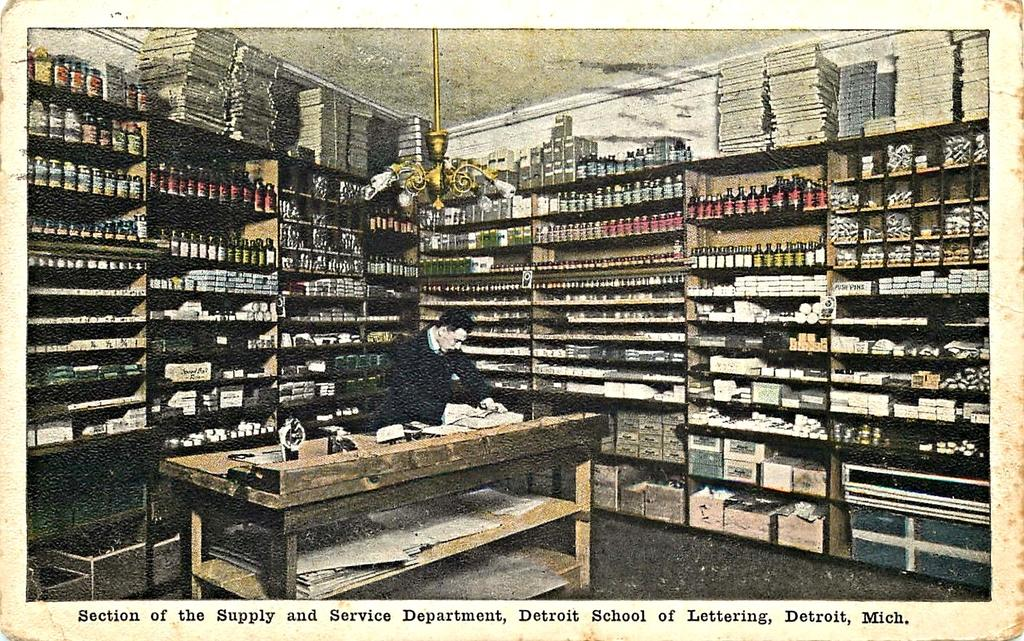<image>
Provide a brief description of the given image. A postcard shows a section of the supply and service department at the Detroit School of Lettering. 